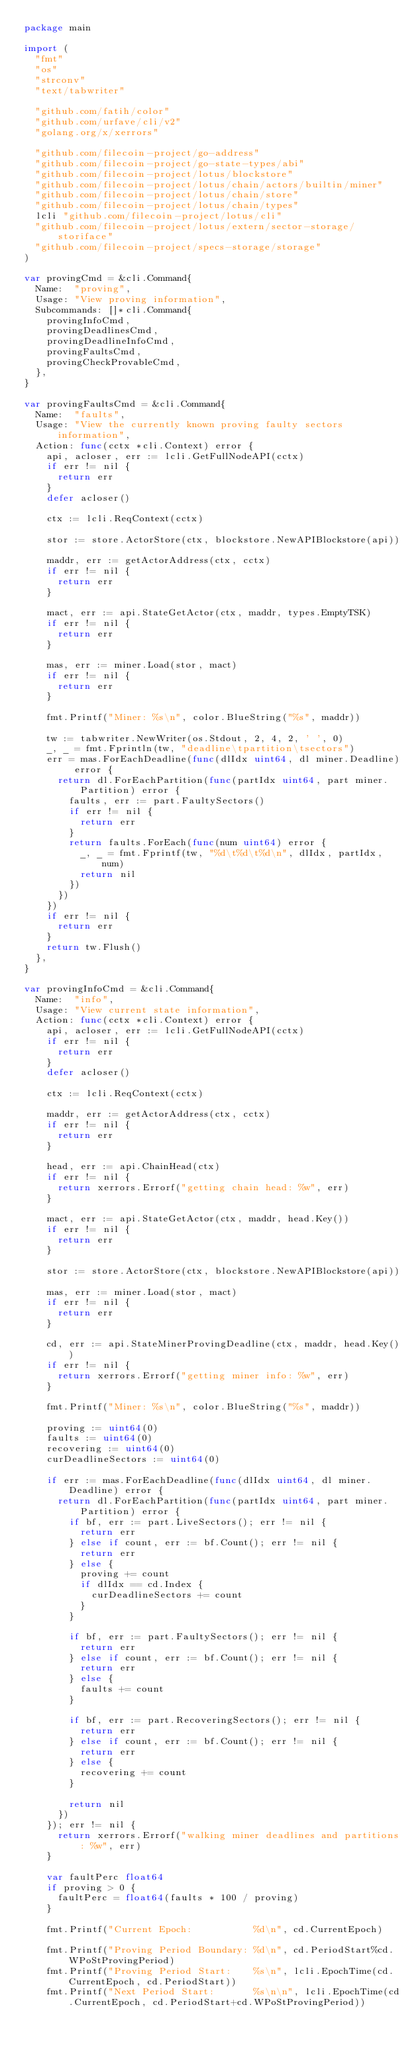<code> <loc_0><loc_0><loc_500><loc_500><_Go_>package main

import (
	"fmt"
	"os"
	"strconv"
	"text/tabwriter"

	"github.com/fatih/color"
	"github.com/urfave/cli/v2"
	"golang.org/x/xerrors"

	"github.com/filecoin-project/go-address"
	"github.com/filecoin-project/go-state-types/abi"
	"github.com/filecoin-project/lotus/blockstore"
	"github.com/filecoin-project/lotus/chain/actors/builtin/miner"
	"github.com/filecoin-project/lotus/chain/store"
	"github.com/filecoin-project/lotus/chain/types"
	lcli "github.com/filecoin-project/lotus/cli"
	"github.com/filecoin-project/lotus/extern/sector-storage/storiface"
	"github.com/filecoin-project/specs-storage/storage"
)

var provingCmd = &cli.Command{
	Name:  "proving",
	Usage: "View proving information",
	Subcommands: []*cli.Command{
		provingInfoCmd,
		provingDeadlinesCmd,
		provingDeadlineInfoCmd,
		provingFaultsCmd,
		provingCheckProvableCmd,
	},
}

var provingFaultsCmd = &cli.Command{
	Name:  "faults",
	Usage: "View the currently known proving faulty sectors information",
	Action: func(cctx *cli.Context) error {
		api, acloser, err := lcli.GetFullNodeAPI(cctx)
		if err != nil {
			return err
		}
		defer acloser()

		ctx := lcli.ReqContext(cctx)

		stor := store.ActorStore(ctx, blockstore.NewAPIBlockstore(api))

		maddr, err := getActorAddress(ctx, cctx)
		if err != nil {
			return err
		}

		mact, err := api.StateGetActor(ctx, maddr, types.EmptyTSK)
		if err != nil {
			return err
		}

		mas, err := miner.Load(stor, mact)
		if err != nil {
			return err
		}

		fmt.Printf("Miner: %s\n", color.BlueString("%s", maddr))

		tw := tabwriter.NewWriter(os.Stdout, 2, 4, 2, ' ', 0)
		_, _ = fmt.Fprintln(tw, "deadline\tpartition\tsectors")
		err = mas.ForEachDeadline(func(dlIdx uint64, dl miner.Deadline) error {
			return dl.ForEachPartition(func(partIdx uint64, part miner.Partition) error {
				faults, err := part.FaultySectors()
				if err != nil {
					return err
				}
				return faults.ForEach(func(num uint64) error {
					_, _ = fmt.Fprintf(tw, "%d\t%d\t%d\n", dlIdx, partIdx, num)
					return nil
				})
			})
		})
		if err != nil {
			return err
		}
		return tw.Flush()
	},
}

var provingInfoCmd = &cli.Command{
	Name:  "info",
	Usage: "View current state information",
	Action: func(cctx *cli.Context) error {
		api, acloser, err := lcli.GetFullNodeAPI(cctx)
		if err != nil {
			return err
		}
		defer acloser()

		ctx := lcli.ReqContext(cctx)

		maddr, err := getActorAddress(ctx, cctx)
		if err != nil {
			return err
		}

		head, err := api.ChainHead(ctx)
		if err != nil {
			return xerrors.Errorf("getting chain head: %w", err)
		}

		mact, err := api.StateGetActor(ctx, maddr, head.Key())
		if err != nil {
			return err
		}

		stor := store.ActorStore(ctx, blockstore.NewAPIBlockstore(api))

		mas, err := miner.Load(stor, mact)
		if err != nil {
			return err
		}

		cd, err := api.StateMinerProvingDeadline(ctx, maddr, head.Key())
		if err != nil {
			return xerrors.Errorf("getting miner info: %w", err)
		}

		fmt.Printf("Miner: %s\n", color.BlueString("%s", maddr))

		proving := uint64(0)
		faults := uint64(0)
		recovering := uint64(0)
		curDeadlineSectors := uint64(0)

		if err := mas.ForEachDeadline(func(dlIdx uint64, dl miner.Deadline) error {
			return dl.ForEachPartition(func(partIdx uint64, part miner.Partition) error {
				if bf, err := part.LiveSectors(); err != nil {
					return err
				} else if count, err := bf.Count(); err != nil {
					return err
				} else {
					proving += count
					if dlIdx == cd.Index {
						curDeadlineSectors += count
					}
				}

				if bf, err := part.FaultySectors(); err != nil {
					return err
				} else if count, err := bf.Count(); err != nil {
					return err
				} else {
					faults += count
				}

				if bf, err := part.RecoveringSectors(); err != nil {
					return err
				} else if count, err := bf.Count(); err != nil {
					return err
				} else {
					recovering += count
				}

				return nil
			})
		}); err != nil {
			return xerrors.Errorf("walking miner deadlines and partitions: %w", err)
		}

		var faultPerc float64
		if proving > 0 {
			faultPerc = float64(faults * 100 / proving)
		}

		fmt.Printf("Current Epoch:           %d\n", cd.CurrentEpoch)

		fmt.Printf("Proving Period Boundary: %d\n", cd.PeriodStart%cd.WPoStProvingPeriod)
		fmt.Printf("Proving Period Start:    %s\n", lcli.EpochTime(cd.CurrentEpoch, cd.PeriodStart))
		fmt.Printf("Next Period Start:       %s\n\n", lcli.EpochTime(cd.CurrentEpoch, cd.PeriodStart+cd.WPoStProvingPeriod))
</code> 